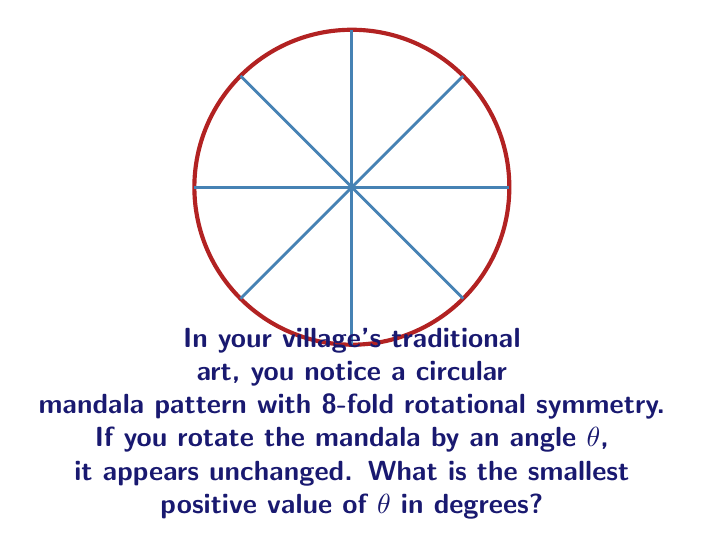Can you answer this question? Let's approach this step-by-step:

1) In a circular pattern with n-fold rotational symmetry, the smallest angle of rotation that leaves the pattern unchanged is given by:

   $$\theta = \frac{360°}{n}$$

   where n is the number of times the pattern repeats in a full rotation.

2) In this case, we're told the mandala has 8-fold rotational symmetry. So, n = 8.

3) Substituting this into our formula:

   $$\theta = \frac{360°}{8}$$

4) Simplifying:

   $$\theta = 45°$$

Therefore, the smallest positive angle of rotation that leaves the mandala unchanged is 45°.
Answer: 45° 